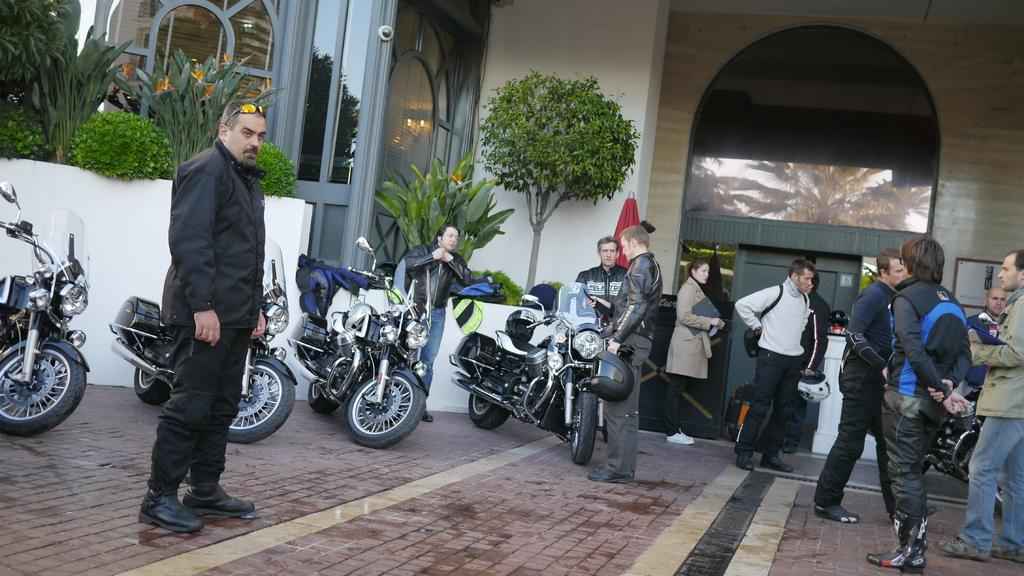What type of surface is visible in the image? There is a pavement in the image. What can be seen on the pavement? There are bikes and people on the pavement. What is visible behind the people? There are plants visible behind the people. What architectural features can be seen in the background of the image? There are doors and walls in the background of the image. How many frogs are sitting on the curtain in the image? There are no frogs or curtains present in the image. 